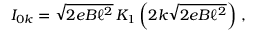<formula> <loc_0><loc_0><loc_500><loc_500>I _ { 0 k } = \sqrt { 2 e B \ell ^ { 2 } } \, K _ { 1 } \left ( 2 k \sqrt { 2 e B \ell ^ { 2 } } \right ) \, ,</formula> 